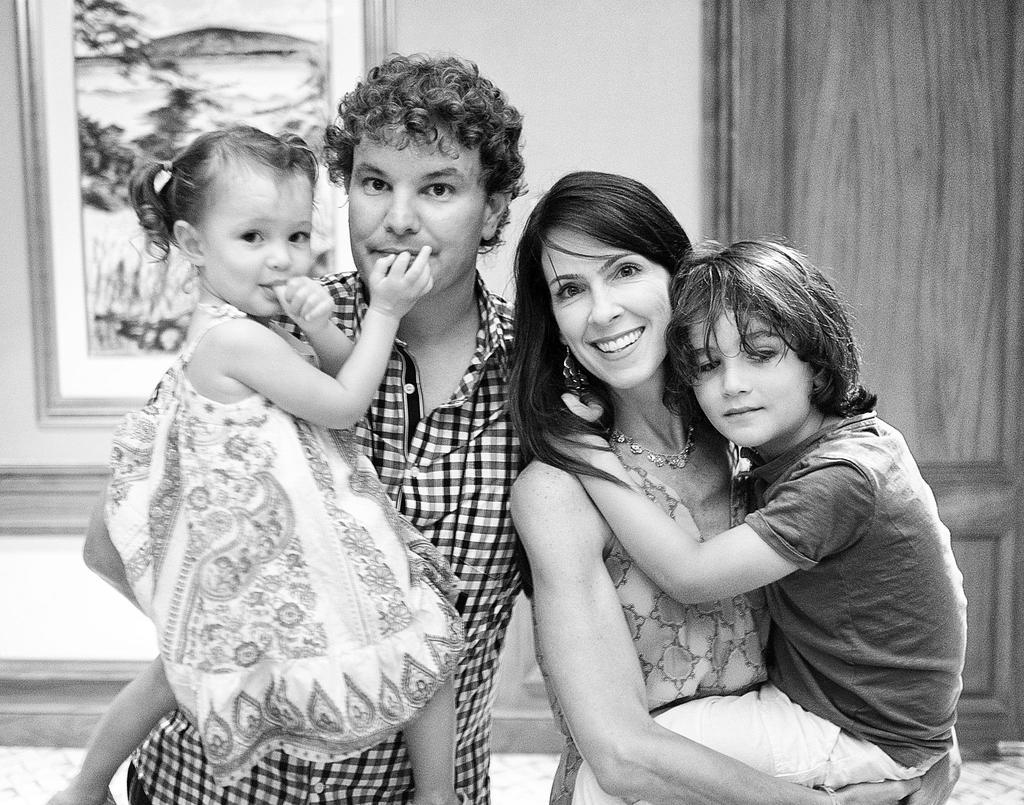Who is present in the image? There is a man and a woman in the image. What are the man and woman doing in the image? The man is holding a girl, and the woman is holding a boy. What is the man wearing in the image? The man is wearing a shirt. What can be seen in the background of the image? There is a wall in the background of the image. Where is the pocket located on the man's shirt in the image? There is no pocket mentioned or visible on the man's shirt in the image. What type of blade is being used by the woman to cut the boy's hair in the image? There is no blade or hair cutting activity present in the image. 